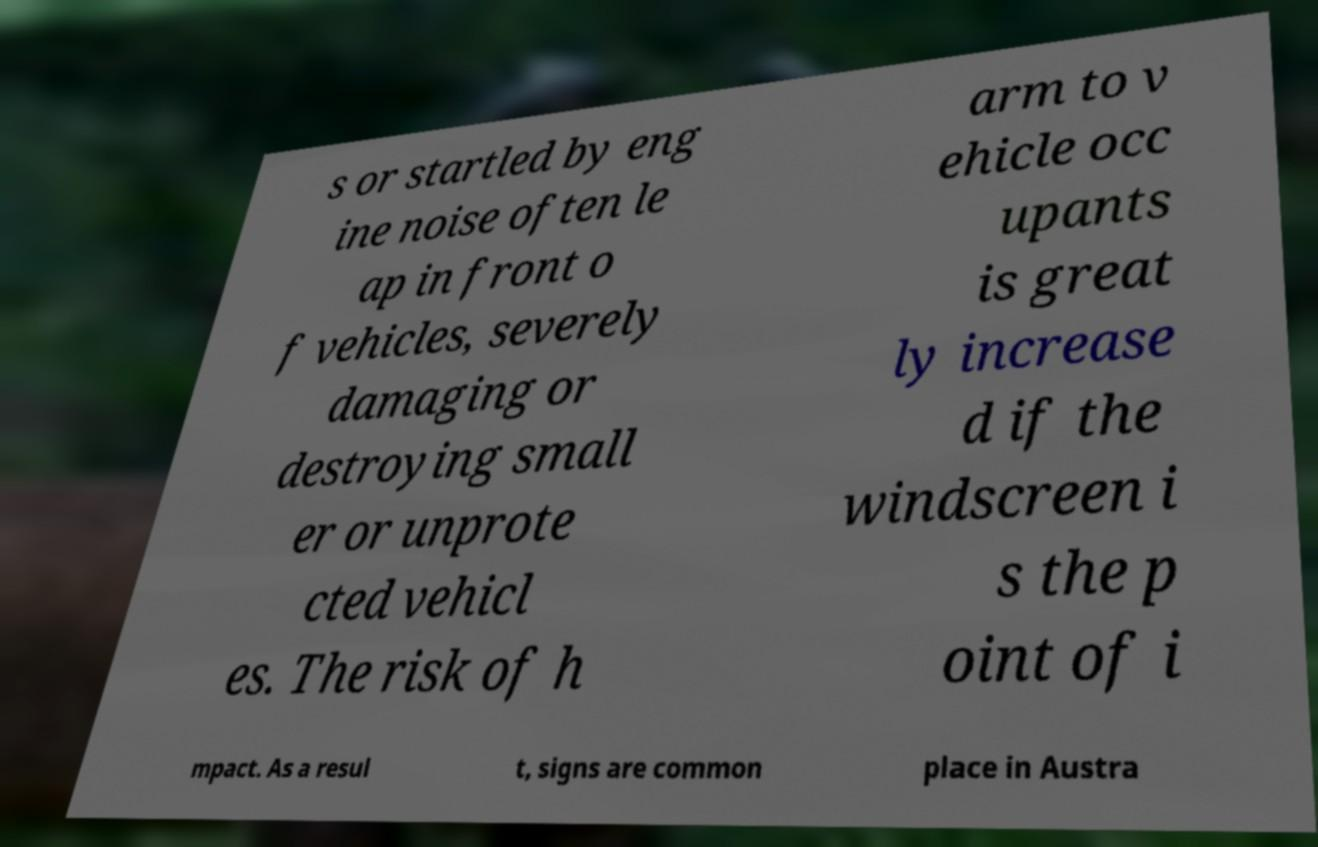For documentation purposes, I need the text within this image transcribed. Could you provide that? s or startled by eng ine noise often le ap in front o f vehicles, severely damaging or destroying small er or unprote cted vehicl es. The risk of h arm to v ehicle occ upants is great ly increase d if the windscreen i s the p oint of i mpact. As a resul t, signs are common place in Austra 